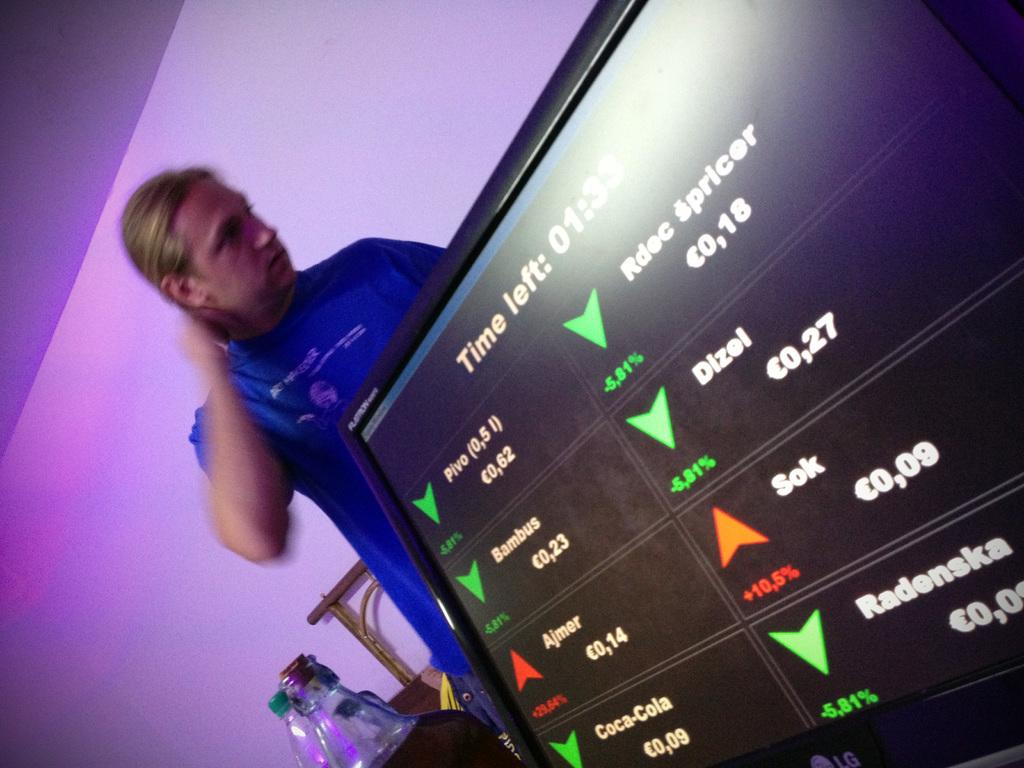<image>
Create a compact narrative representing the image presented. a screen reading Time Left with a person behind it 